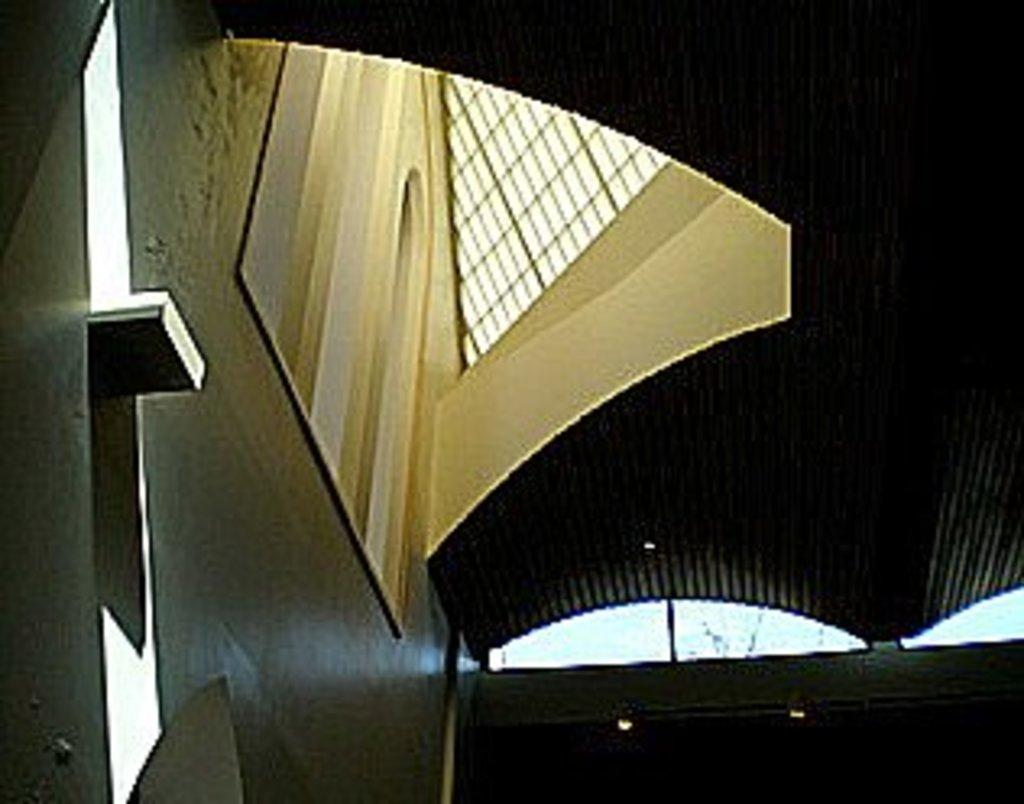What type of location is depicted in the image? The image is of the inside of a building. What can be seen above the objects and people in the image? There is a ceiling in the image. What provides illumination in the image? There are lights in the image. What vertical structures are present in the image? There are poles in the image. Can you describe any other objects or features in the image? There are unspecified objects in the image. What type of rose is growing in the park in the image? There is no rose or park present in the image; it depicts the inside of a building. 